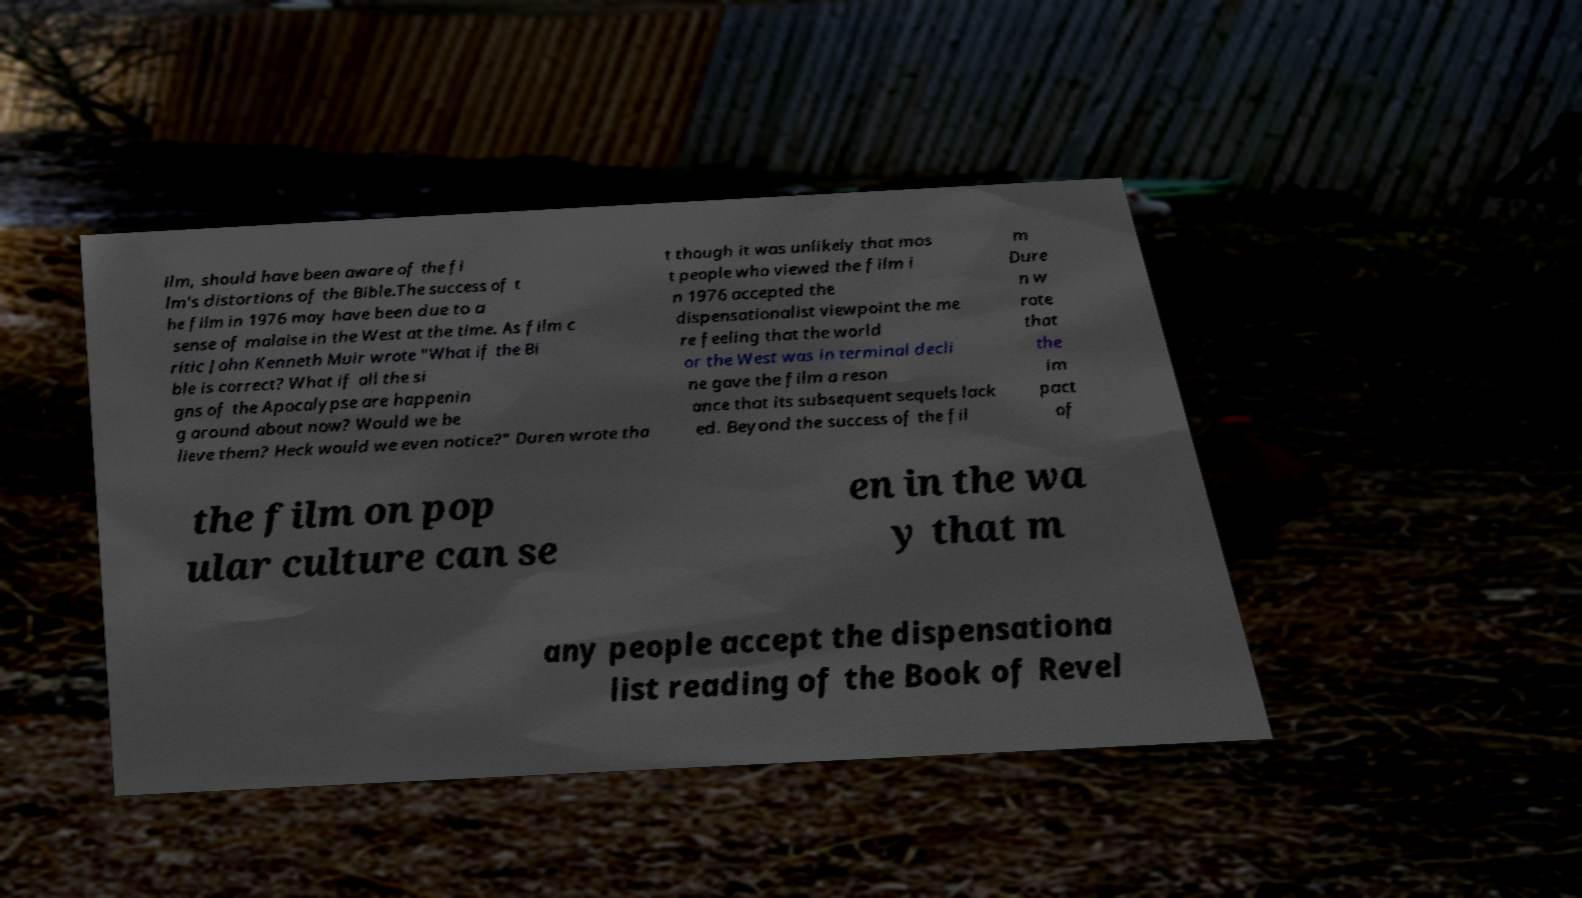I need the written content from this picture converted into text. Can you do that? ilm, should have been aware of the fi lm's distortions of the Bible.The success of t he film in 1976 may have been due to a sense of malaise in the West at the time. As film c ritic John Kenneth Muir wrote "What if the Bi ble is correct? What if all the si gns of the Apocalypse are happenin g around about now? Would we be lieve them? Heck would we even notice?" Duren wrote tha t though it was unlikely that mos t people who viewed the film i n 1976 accepted the dispensationalist viewpoint the me re feeling that the world or the West was in terminal decli ne gave the film a reson ance that its subsequent sequels lack ed. Beyond the success of the fil m Dure n w rote that the im pact of the film on pop ular culture can se en in the wa y that m any people accept the dispensationa list reading of the Book of Revel 